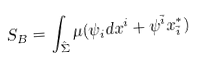Convert formula to latex. <formula><loc_0><loc_0><loc_500><loc_500>S _ { B } = \int _ { \hat { \Sigma } } \mu ( \psi _ { i } d x ^ { i } + \psi ^ { \bar { i } } x _ { \bar { i } } ^ { * } )</formula> 